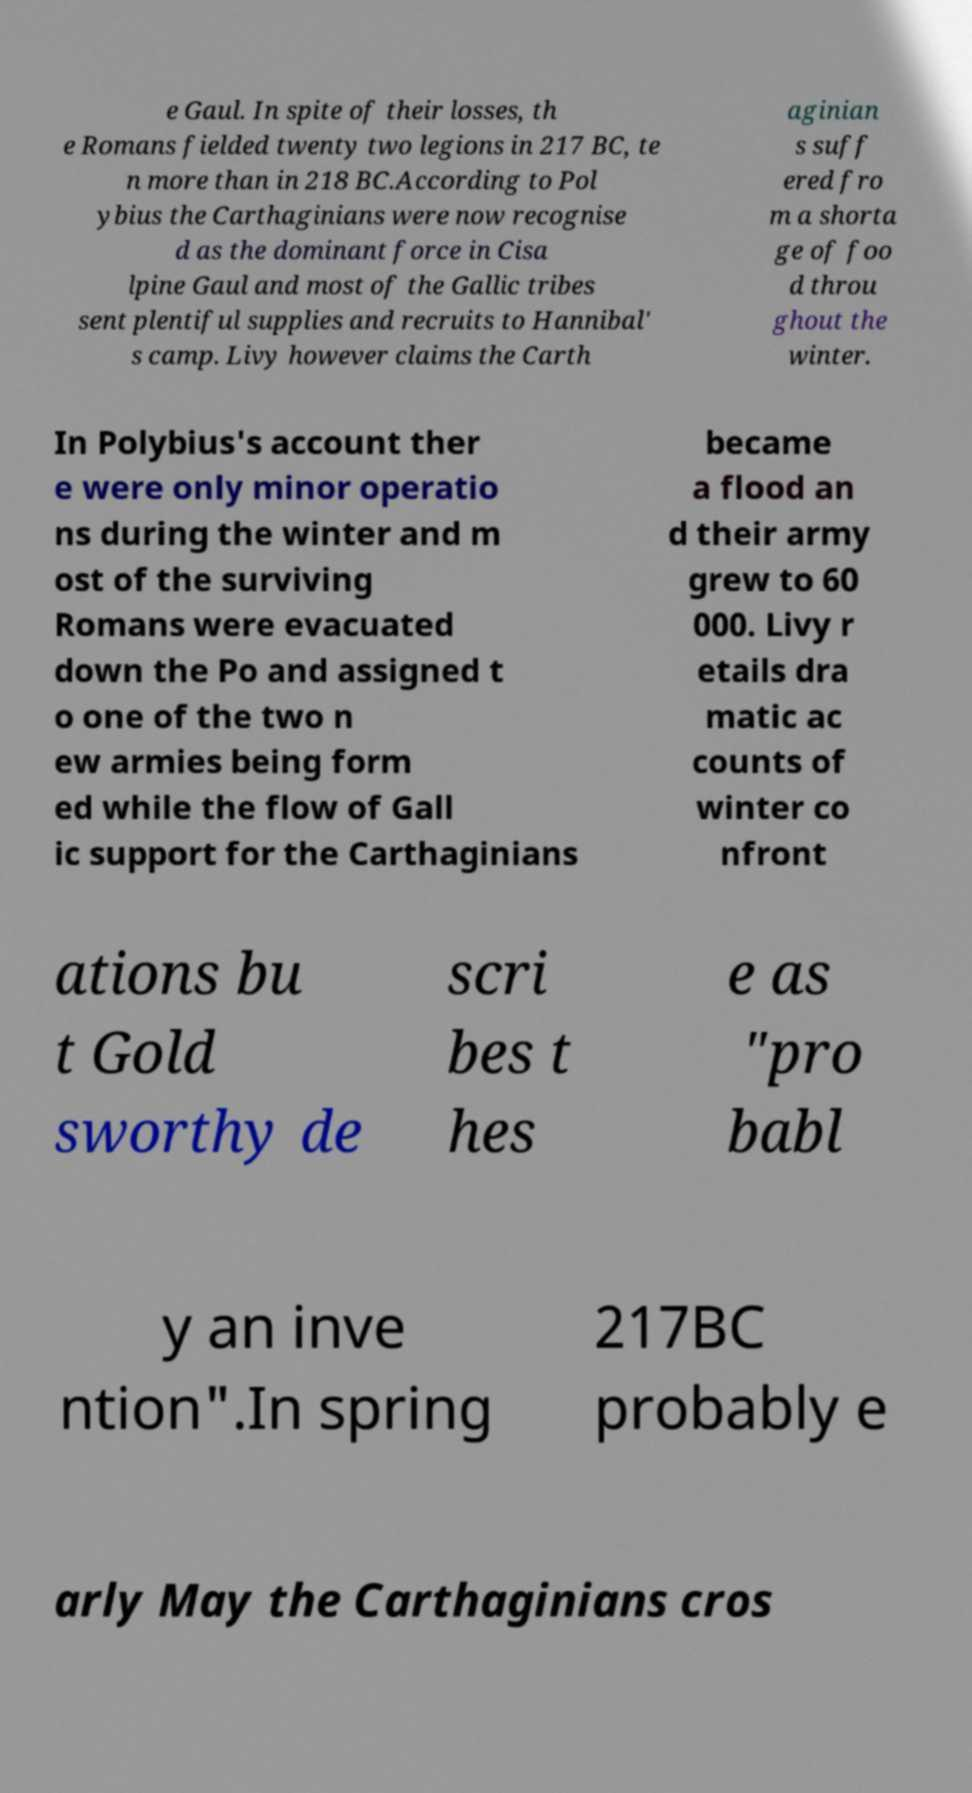Could you assist in decoding the text presented in this image and type it out clearly? e Gaul. In spite of their losses, th e Romans fielded twenty two legions in 217 BC, te n more than in 218 BC.According to Pol ybius the Carthaginians were now recognise d as the dominant force in Cisa lpine Gaul and most of the Gallic tribes sent plentiful supplies and recruits to Hannibal' s camp. Livy however claims the Carth aginian s suff ered fro m a shorta ge of foo d throu ghout the winter. In Polybius's account ther e were only minor operatio ns during the winter and m ost of the surviving Romans were evacuated down the Po and assigned t o one of the two n ew armies being form ed while the flow of Gall ic support for the Carthaginians became a flood an d their army grew to 60 000. Livy r etails dra matic ac counts of winter co nfront ations bu t Gold sworthy de scri bes t hes e as "pro babl y an inve ntion".In spring 217BC probably e arly May the Carthaginians cros 